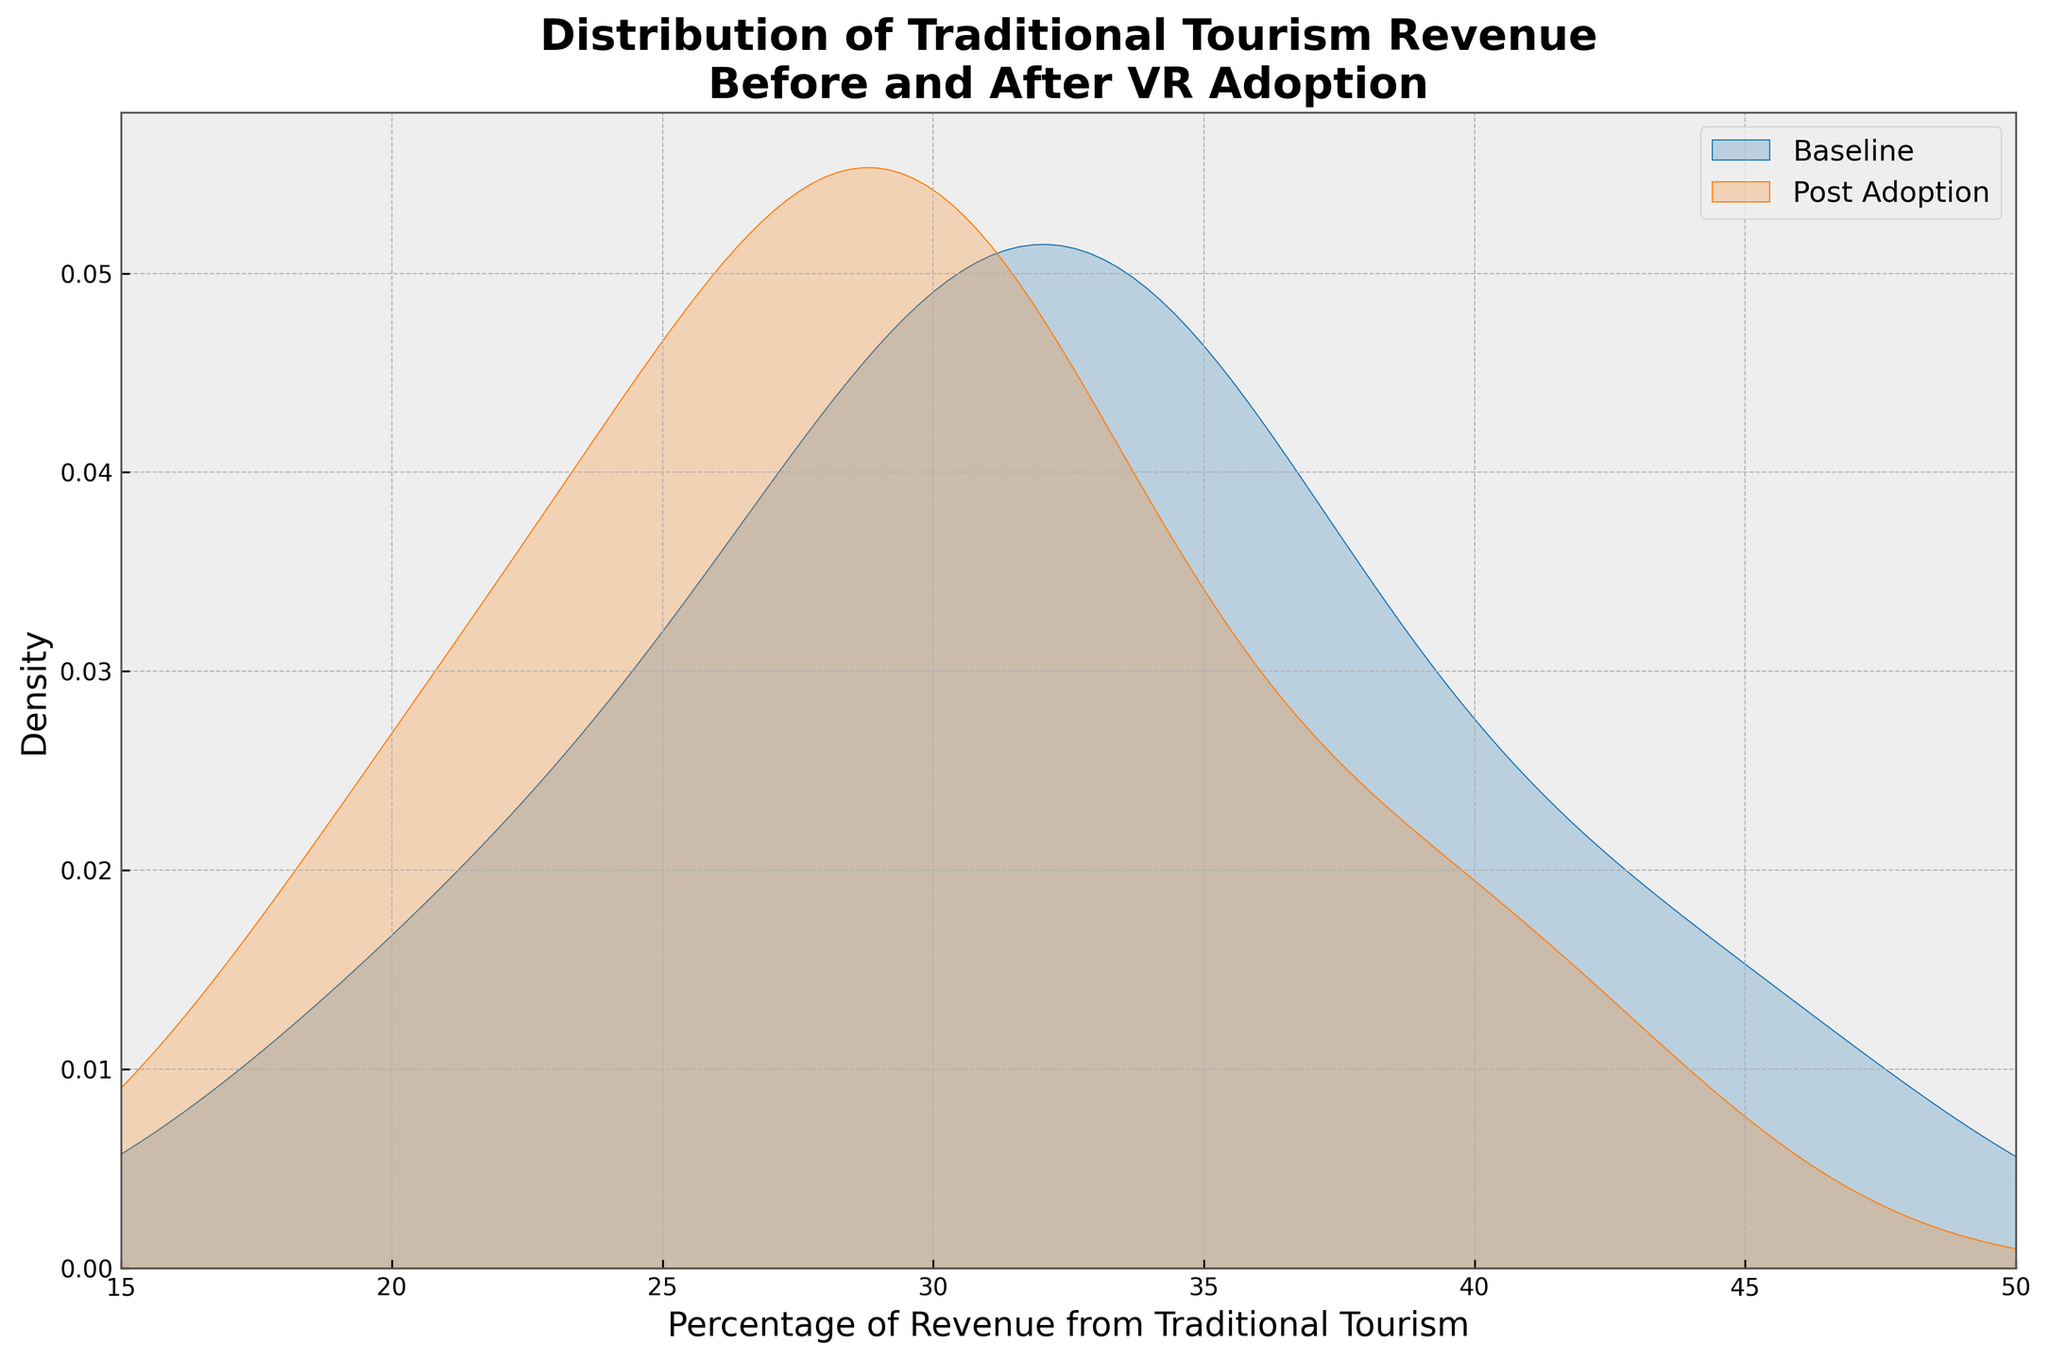What's the title of the figure? The title is usually displayed at the top of the figure. Here, it reads "Distribution of Traditional Tourism Revenue\nBefore and After VR Adoption."
Answer: Distribution of Traditional Tourism Revenue Before and After VR Adoption What is the x-axis label? The x-axis label is found along the horizontal axis of the graph. It reads "Percentage of Revenue from Traditional Tourism."
Answer: Percentage of Revenue from Traditional Tourism What color is used to represent the baseline distribution? The color representing the baseline distribution is identified in the legend on the right-hand side of the plot. It is blue.
Answer: Blue Which distribution has a higher peak density, baseline or post-adoption? Look at the peak height of each density curve; the post-adoption (orange) has a higher peak density compared to the baseline (blue).
Answer: Post-adoption What percentage range is covered by the x-axis? The x-axis ranges from 15% to 50%, as shown by the ticks and limits provided on that axis.
Answer: 15% to 50% How do the baseline and post-adoption distributions compare in terms of the shift from left to right? The baseline distribution (blue) appears to shift slightly to the right post-adoption (orange), indicating a decrease in the percentage of revenue from traditional tourism. The peak has moved from around 30-35% to approximately 25-30%.
Answer: There is a slight shift to the left Why is the post-adoption distribution denser in the 25-30% range? The density in a kernel density estimate plot indicates where data points are concentrated. A denser area in the post-adoption distribution (orange) in the 25-30% range means more regions have traditional tourism revenue in that percentage after adopting VR technology.
Answer: More regions have traditional tourism revenue in the 25-30% range post-adoption Which distribution's peak lies more towards the higher percentage of traditional tourism revenue? Comparing the peak positions of both curves, the baseline distribution (blue) has its peak more towards the higher percentages around 30-35%.
Answer: Baseline distribution What inference can you make about the impact of VR adoption on traditional tourism revenue based on the shift in the distributions? The shift of the entire distribution to the left for post-adoption implies that VR technology adoption might be associated with a slight decrease in revenue percentage from traditional tourism sectors.
Answer: Slight decrease in traditional tourism revenue percentage 